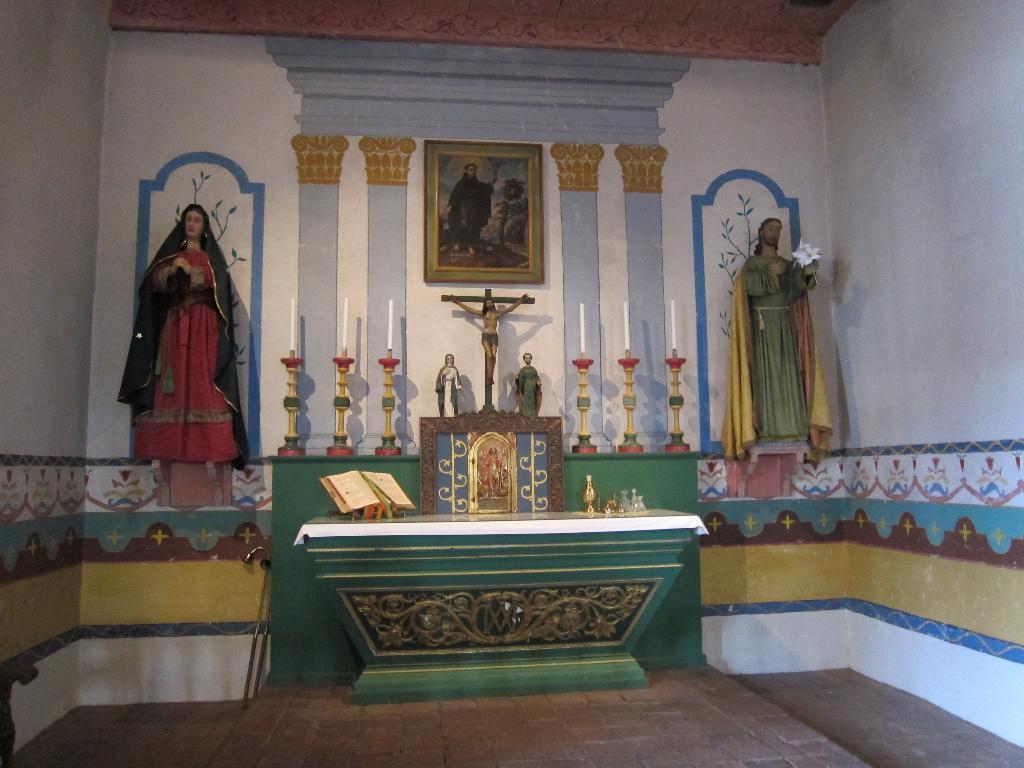Please provide a concise description of this image. It is an inside view of the church. Here we can see some sculptures, photo frames, candle with stands, book, few objects, table. At the bottom, there so a floor. Background we can see wall with few designs. 